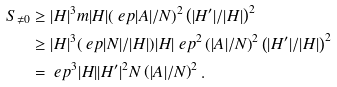<formula> <loc_0><loc_0><loc_500><loc_500>S _ { \neq 0 } & \geq | H | ^ { 3 } m | H | ( \ e p | A | / N ) ^ { 2 } \left ( | H ^ { \prime } | / | H | \right ) ^ { 2 } \\ & \geq | H | ^ { 3 } ( \ e p | N | / | H | ) | H | \ e p ^ { 2 } \left ( | A | / N \right ) ^ { 2 } \left ( | H ^ { \prime } | / | H | \right ) ^ { 2 } \\ & = \ e p ^ { 3 } | H | | H ^ { \prime } | ^ { 2 } N \left ( | A | / N \right ) ^ { 2 } .</formula> 